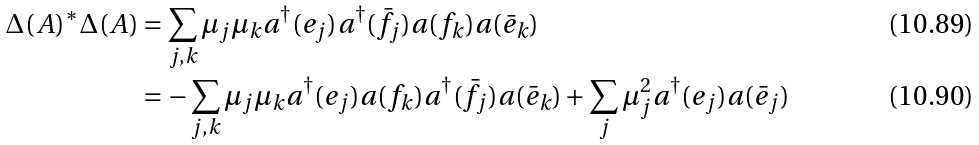Convert formula to latex. <formula><loc_0><loc_0><loc_500><loc_500>\Delta ( A ) ^ { * } \Delta ( A ) & = \sum _ { j , k } \mu _ { j } \mu _ { k } a ^ { \dagger } ( e _ { j } ) a ^ { \dagger } ( \bar { f } _ { j } ) a ( f _ { k } ) a ( \bar { e } _ { k } ) \\ & = - \sum _ { j , k } \mu _ { j } \mu _ { k } a ^ { \dagger } ( e _ { j } ) a ( f _ { k } ) a ^ { \dagger } ( \bar { f } _ { j } ) a ( \bar { e } _ { k } ) + \sum _ { j } \mu _ { j } ^ { 2 } a ^ { \dagger } ( e _ { j } ) a ( \bar { e } _ { j } )</formula> 